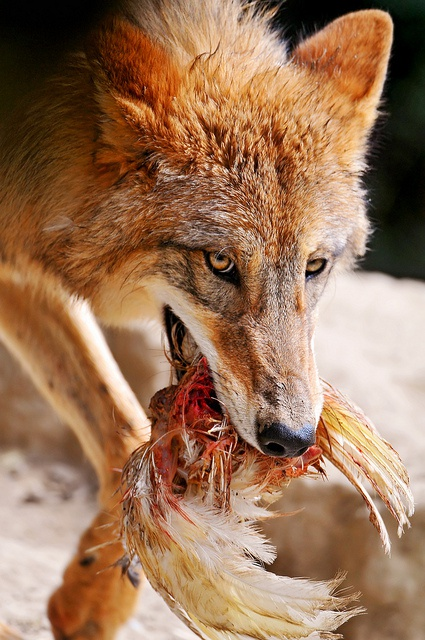Describe the objects in this image and their specific colors. I can see dog in black, brown, maroon, and tan tones and bird in black, tan, maroon, and brown tones in this image. 